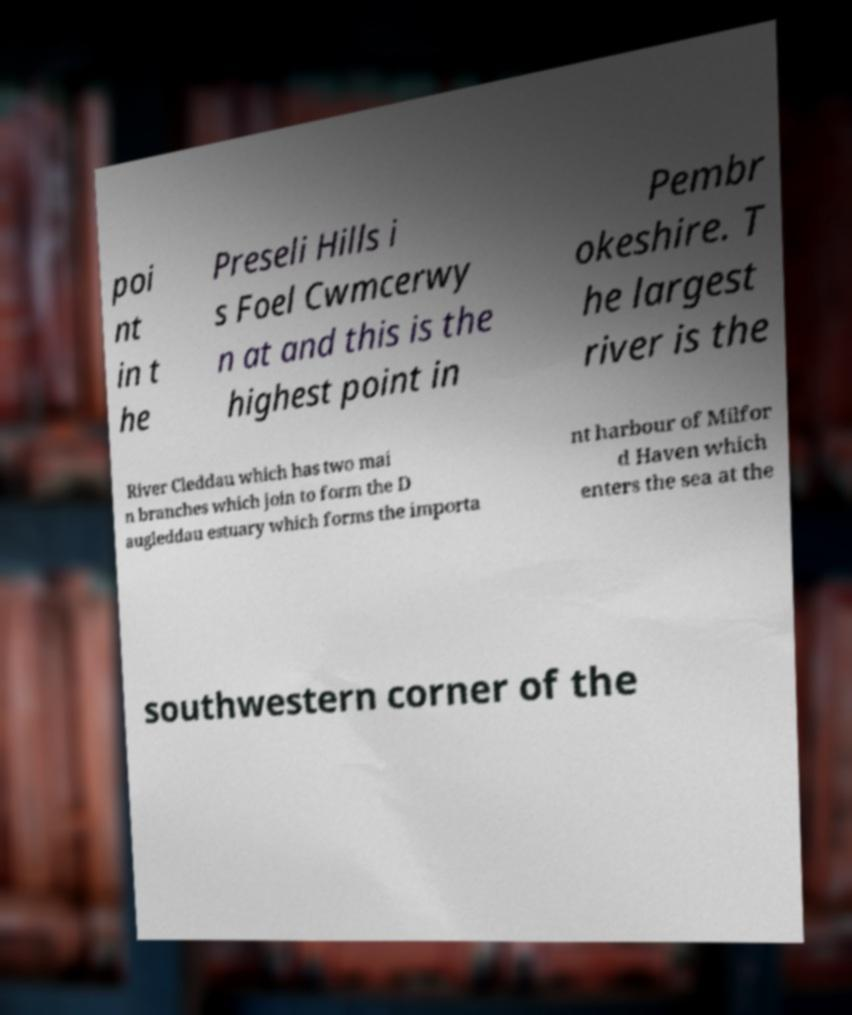Could you extract and type out the text from this image? poi nt in t he Preseli Hills i s Foel Cwmcerwy n at and this is the highest point in Pembr okeshire. T he largest river is the River Cleddau which has two mai n branches which join to form the D augleddau estuary which forms the importa nt harbour of Milfor d Haven which enters the sea at the southwestern corner of the 